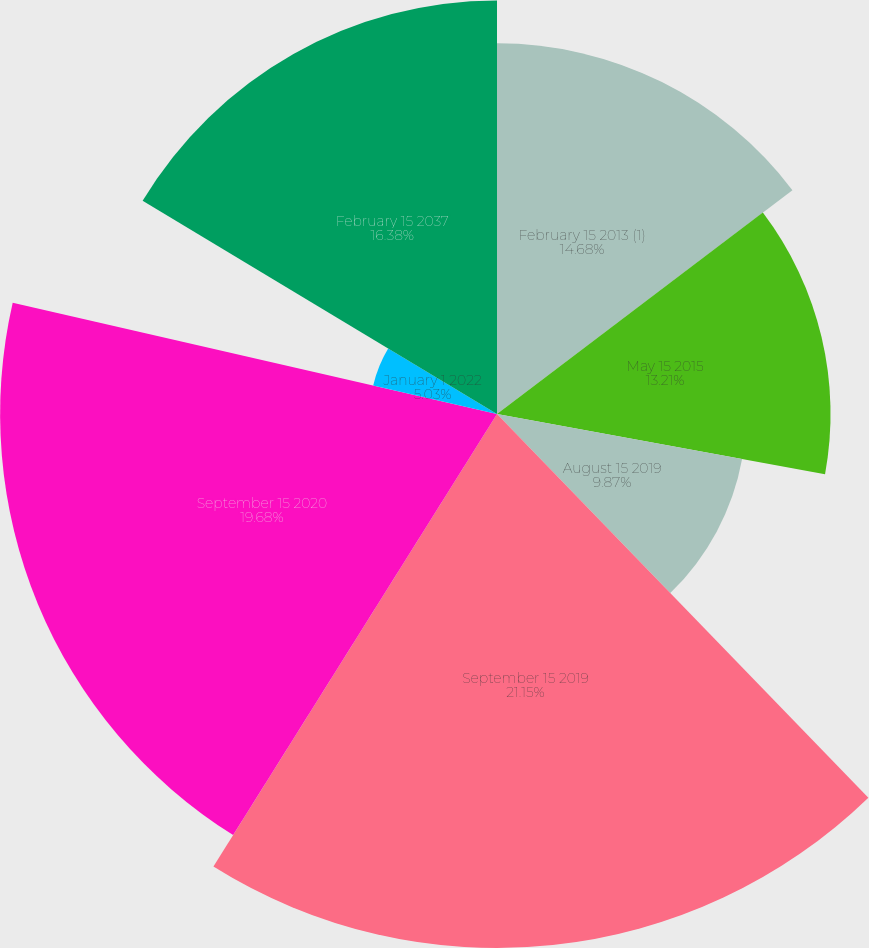<chart> <loc_0><loc_0><loc_500><loc_500><pie_chart><fcel>February 15 2013 (1)<fcel>May 15 2015<fcel>August 15 2019<fcel>September 15 2019<fcel>September 15 2020<fcel>January 1 2022<fcel>February 15 2037<nl><fcel>14.68%<fcel>13.21%<fcel>9.87%<fcel>21.15%<fcel>19.68%<fcel>5.03%<fcel>16.38%<nl></chart> 